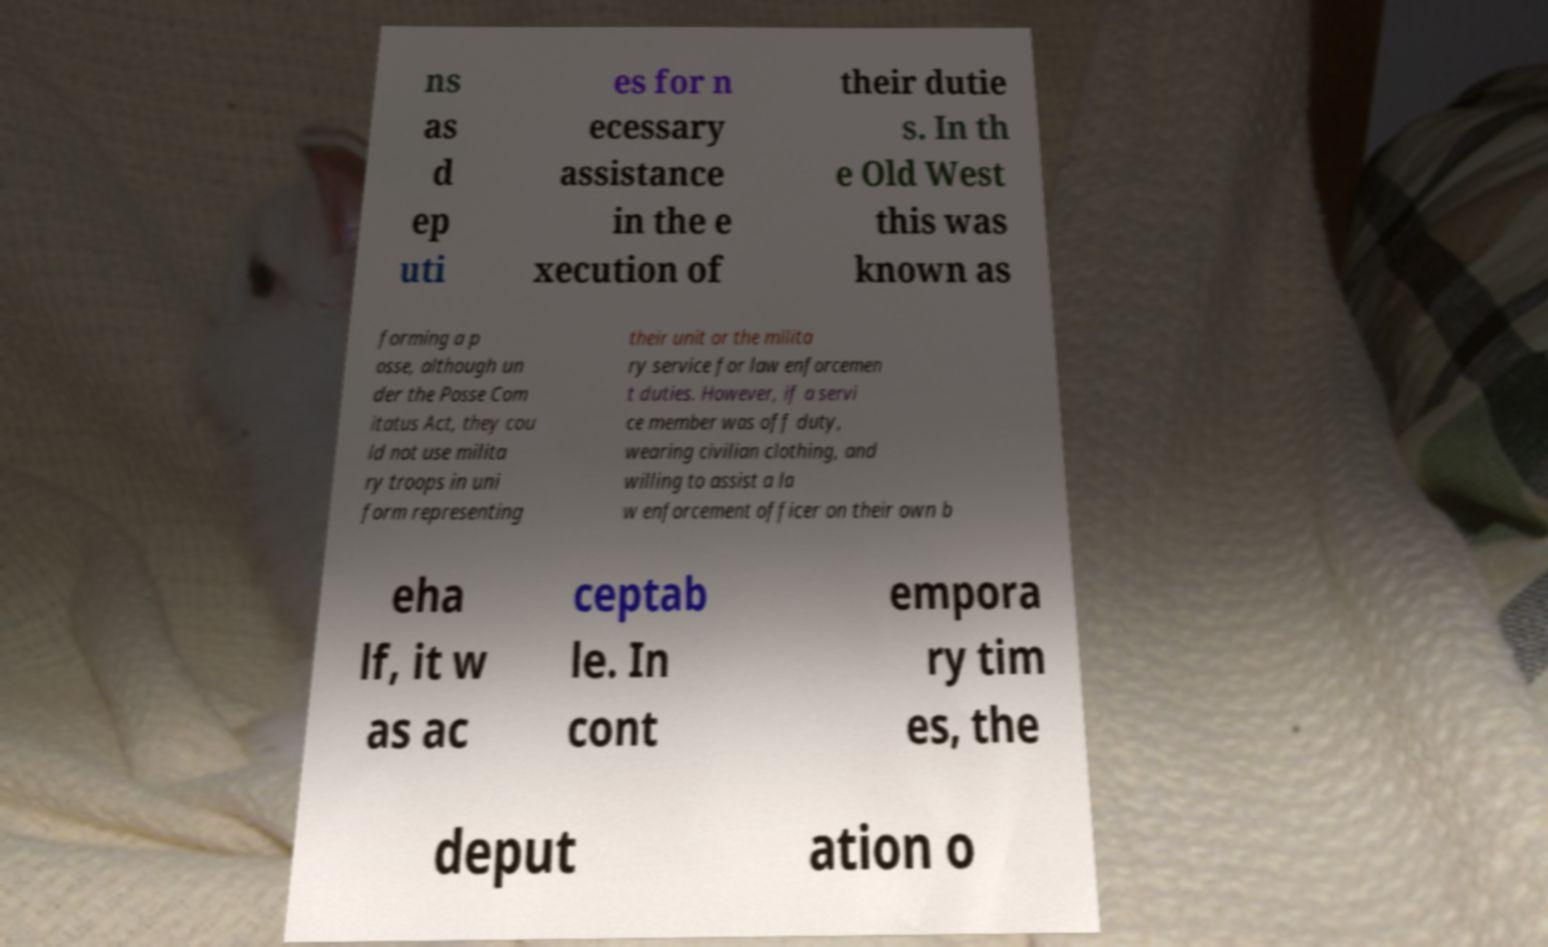Could you assist in decoding the text presented in this image and type it out clearly? ns as d ep uti es for n ecessary assistance in the e xecution of their dutie s. In th e Old West this was known as forming a p osse, although un der the Posse Com itatus Act, they cou ld not use milita ry troops in uni form representing their unit or the milita ry service for law enforcemen t duties. However, if a servi ce member was off duty, wearing civilian clothing, and willing to assist a la w enforcement officer on their own b eha lf, it w as ac ceptab le. In cont empora ry tim es, the deput ation o 